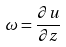<formula> <loc_0><loc_0><loc_500><loc_500>\omega = \frac { \partial u } { \partial z }</formula> 